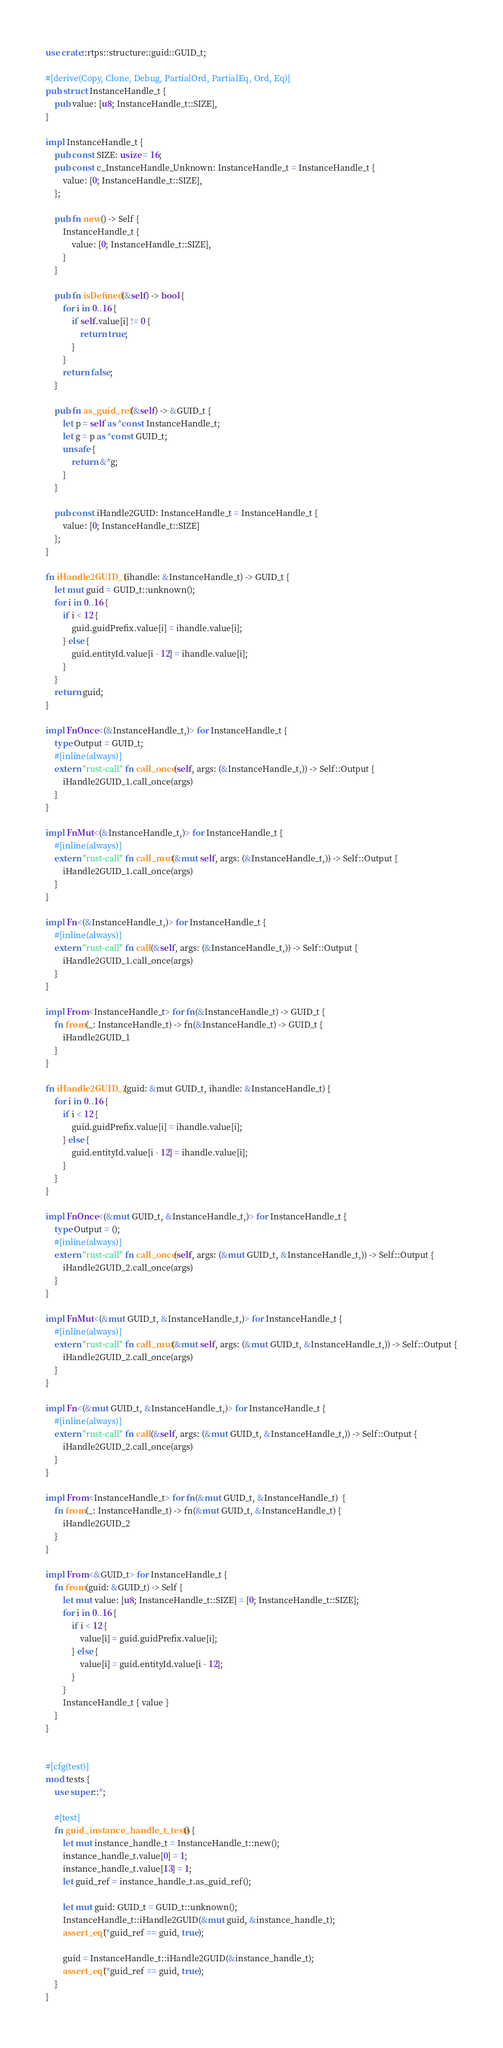Convert code to text. <code><loc_0><loc_0><loc_500><loc_500><_Rust_>use crate::rtps::structure::guid::GUID_t;

#[derive(Copy, Clone, Debug, PartialOrd, PartialEq, Ord, Eq)]
pub struct InstanceHandle_t {
    pub value: [u8; InstanceHandle_t::SIZE],
}

impl InstanceHandle_t {
    pub const SIZE: usize = 16;
    pub const c_InstanceHandle_Unknown: InstanceHandle_t = InstanceHandle_t {
        value: [0; InstanceHandle_t::SIZE],
    };

    pub fn new() -> Self {
        InstanceHandle_t {
            value: [0; InstanceHandle_t::SIZE],
        }
    }

    pub fn isDefined(&self) -> bool {
        for i in 0..16 {
            if self.value[i] != 0 {
                return true;
            }
        }
        return false;
    }

    pub fn as_guid_ref(&self) -> &GUID_t {
        let p = self as *const InstanceHandle_t;
        let g = p as *const GUID_t;
        unsafe {
            return &*g;
        }
    }

    pub const iHandle2GUID: InstanceHandle_t = InstanceHandle_t {
        value: [0; InstanceHandle_t::SIZE]
    };
}

fn iHandle2GUID_1(ihandle: &InstanceHandle_t) -> GUID_t {
    let mut guid = GUID_t::unknown();
    for i in 0..16 {
        if i < 12 {
            guid.guidPrefix.value[i] = ihandle.value[i];
        } else {
            guid.entityId.value[i - 12] = ihandle.value[i];
        }
    }
    return guid;
}

impl FnOnce<(&InstanceHandle_t,)> for InstanceHandle_t {
    type Output = GUID_t;
    #[inline(always)]
    extern "rust-call" fn call_once(self, args: (&InstanceHandle_t,)) -> Self::Output {
        iHandle2GUID_1.call_once(args)
    }
}

impl FnMut<(&InstanceHandle_t,)> for InstanceHandle_t {
    #[inline(always)]
    extern "rust-call" fn call_mut(&mut self, args: (&InstanceHandle_t,)) -> Self::Output {
        iHandle2GUID_1.call_once(args)
    }
}

impl Fn<(&InstanceHandle_t,)> for InstanceHandle_t {
    #[inline(always)]
    extern "rust-call" fn call(&self, args: (&InstanceHandle_t,)) -> Self::Output {
        iHandle2GUID_1.call_once(args)
    }
}

impl From<InstanceHandle_t> for fn(&InstanceHandle_t) -> GUID_t {
    fn from(_: InstanceHandle_t) -> fn(&InstanceHandle_t) -> GUID_t {
        iHandle2GUID_1
    }
}

fn iHandle2GUID_2(guid: &mut GUID_t, ihandle: &InstanceHandle_t) {
    for i in 0..16 {
        if i < 12 {
            guid.guidPrefix.value[i] = ihandle.value[i];
        } else {
            guid.entityId.value[i - 12] = ihandle.value[i];
        }
    }
}

impl FnOnce<(&mut GUID_t, &InstanceHandle_t,)> for InstanceHandle_t {
    type Output = ();
    #[inline(always)]
    extern "rust-call" fn call_once(self, args: (&mut GUID_t, &InstanceHandle_t,)) -> Self::Output {
        iHandle2GUID_2.call_once(args)
    }
}

impl FnMut<(&mut GUID_t, &InstanceHandle_t,)> for InstanceHandle_t {
    #[inline(always)]
    extern "rust-call" fn call_mut(&mut self, args: (&mut GUID_t, &InstanceHandle_t,)) -> Self::Output {
        iHandle2GUID_2.call_once(args)
    }
}

impl Fn<(&mut GUID_t, &InstanceHandle_t,)> for InstanceHandle_t {
    #[inline(always)]
    extern "rust-call" fn call(&self, args: (&mut GUID_t, &InstanceHandle_t,)) -> Self::Output {
        iHandle2GUID_2.call_once(args)
    }
}

impl From<InstanceHandle_t> for fn(&mut GUID_t, &InstanceHandle_t)  {
    fn from(_: InstanceHandle_t) -> fn(&mut GUID_t, &InstanceHandle_t) {
        iHandle2GUID_2
    }
}

impl From<&GUID_t> for InstanceHandle_t {
    fn from(guid: &GUID_t) -> Self {
        let mut value: [u8; InstanceHandle_t::SIZE] = [0; InstanceHandle_t::SIZE];
        for i in 0..16 {
            if i < 12 {
                value[i] = guid.guidPrefix.value[i];
            } else {
                value[i] = guid.entityId.value[i - 12];
            }
        }
        InstanceHandle_t { value }
    }
}


#[cfg(test)]
mod tests {
    use super::*;

    #[test]
    fn guid_instance_handle_t_tests() {
        let mut instance_handle_t = InstanceHandle_t::new();
        instance_handle_t.value[0] = 1;
        instance_handle_t.value[13] = 1;
        let guid_ref = instance_handle_t.as_guid_ref();

        let mut guid: GUID_t = GUID_t::unknown();
        InstanceHandle_t::iHandle2GUID(&mut guid, &instance_handle_t);
        assert_eq!(*guid_ref == guid, true);

        guid = InstanceHandle_t::iHandle2GUID(&instance_handle_t);
        assert_eq!(*guid_ref == guid, true);
    }
}
</code> 